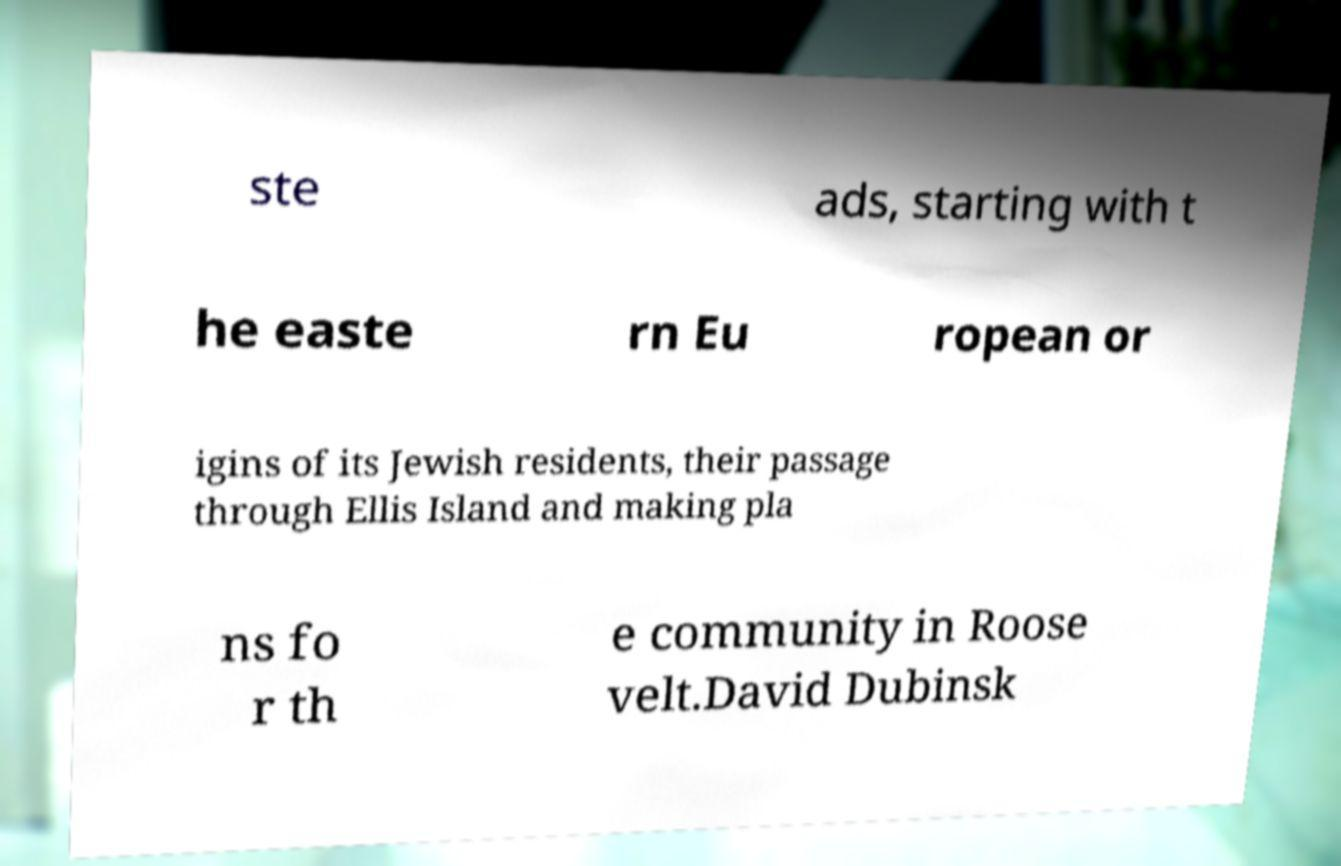Please read and relay the text visible in this image. What does it say? ste ads, starting with t he easte rn Eu ropean or igins of its Jewish residents, their passage through Ellis Island and making pla ns fo r th e community in Roose velt.David Dubinsk 